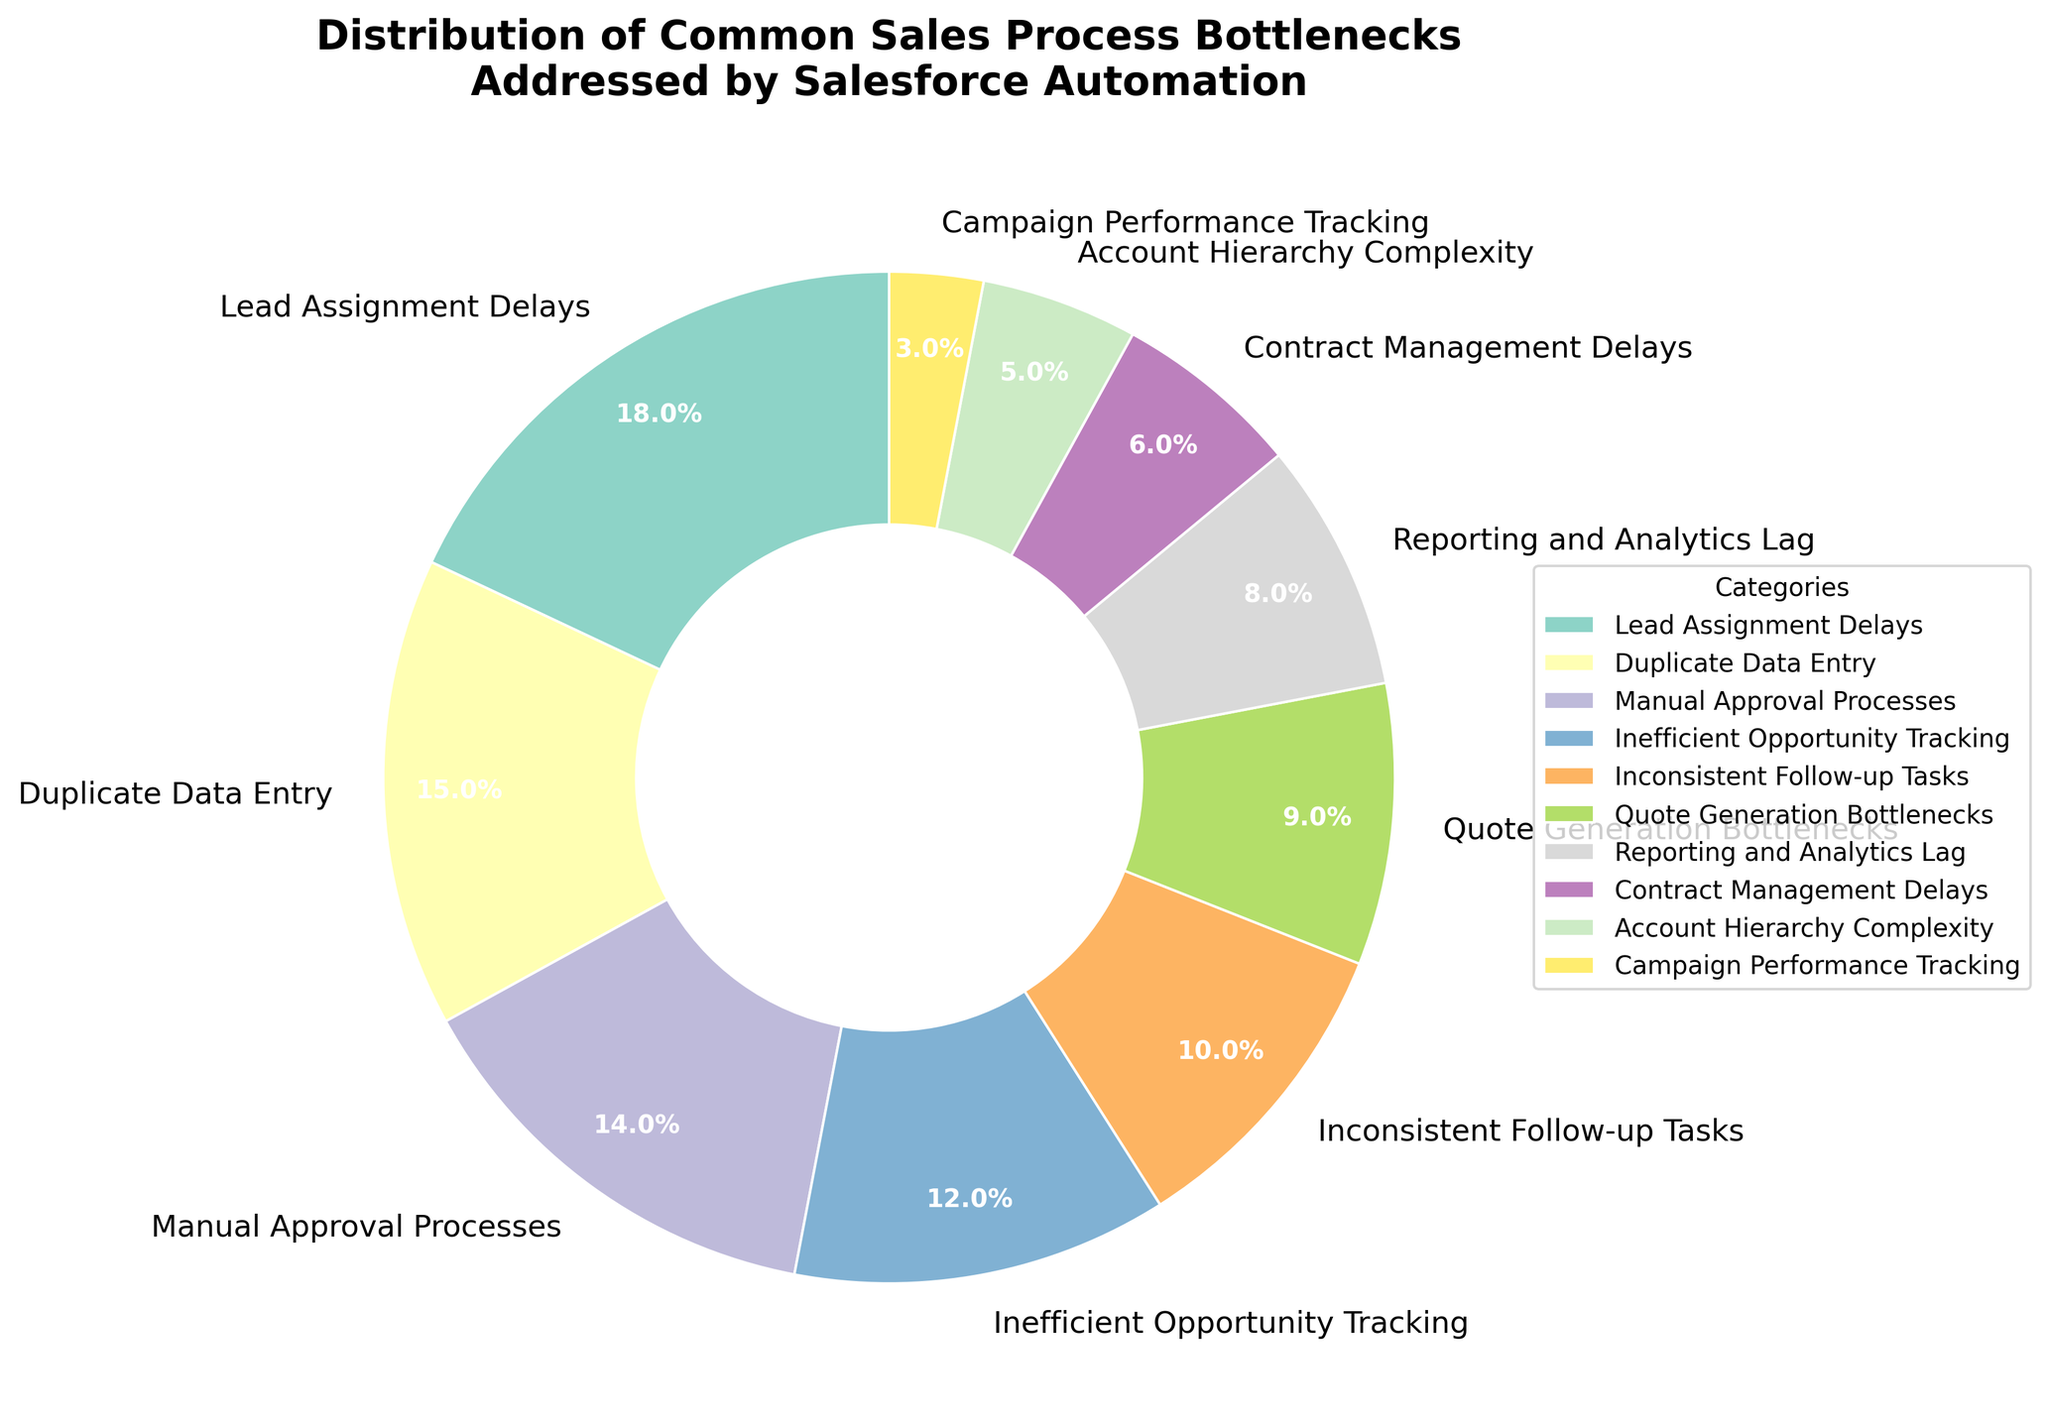What percentage of sales bottlenecks are due to Lead Assignment Delays and Manual Approval Processes combined? First, identify the percentages attributed to Lead Assignment Delays (18%) and Manual Approval Processes (14%). Then, sum these percentages: 18% + 14% = 32%.
Answer: 32% Which category has the smallest percentage and what is its exact percentage? Look for the smallest section in the pie chart. The category is Campaign Performance Tracking, which has a percentage of 3%.
Answer: Campaign Performance Tracking, 3% How much more common are Lead Assignment Delays than Quote Generation Bottlenecks? Identify the percentages for Lead Assignment Delays (18%) and Quote Generation Bottlenecks (9%). Subtract the smaller percentage from the larger: 18% - 9% = 9%.
Answer: 9% Which categories together make up exactly 25% of the sales process bottlenecks? Look for combinations that sum up to 25%. Contract Management Delays (6%) and Account Hierarchy Complexity (5%) together make 11%. Finally, add Campaign Performance Tracking (3%) to get: 6% + 5% + 3% + 3% + 8% = 25%.
Answer: Contract Management Delays, Account Hierarchy Complexity, Campaign Performance Tracking and Reporting and Analytics Lag What is the combined percentage of all categories related to data handling issues (Duplicate Data Entry and Reporting and Analytics Lag)? Identify the percentages for Duplicate Data Entry (15%) and Reporting and Analytics Lag (8%). Add these percentages: 15% + 8% = 23%.
Answer: 23% Which category has almost double the percentage of Account Hierarchy Complexity? Identify the percentage for Account Hierarchy Complexity (5%) and find the closest category that is nearly double. Manual Approval Processes at 14% is not close, but Duplicate Data Entry at 15% is close to double 5%, but instead, Lead Assignment is the closest to be double.
Answer: Lead Assignment Delays, 18% If the least significant five bottlenecks were resolved, what percentage of issues would remain? Identify the percentages of the least significant five categories: Campaign Performance Tracking (3%), Account Hierarchy Complexity (5%), Contract Management Delays (6%), Reporting and Analytics Lag (8%), and Quote Generation Bottlenecks (9%). Sum these percentages: 3% + 5% + 6% + 8% + 9% = 31%. So, 100% - 31% = 69%.
Answer: 69% What is the color used for the Inefficient Opportunity Tracking category in the pie chart? Observe the color used in the pie chart segment corresponding to Inefficient Opportunity Tracking.
Answer: Color of Inefficient Opportunity Tracking is green 